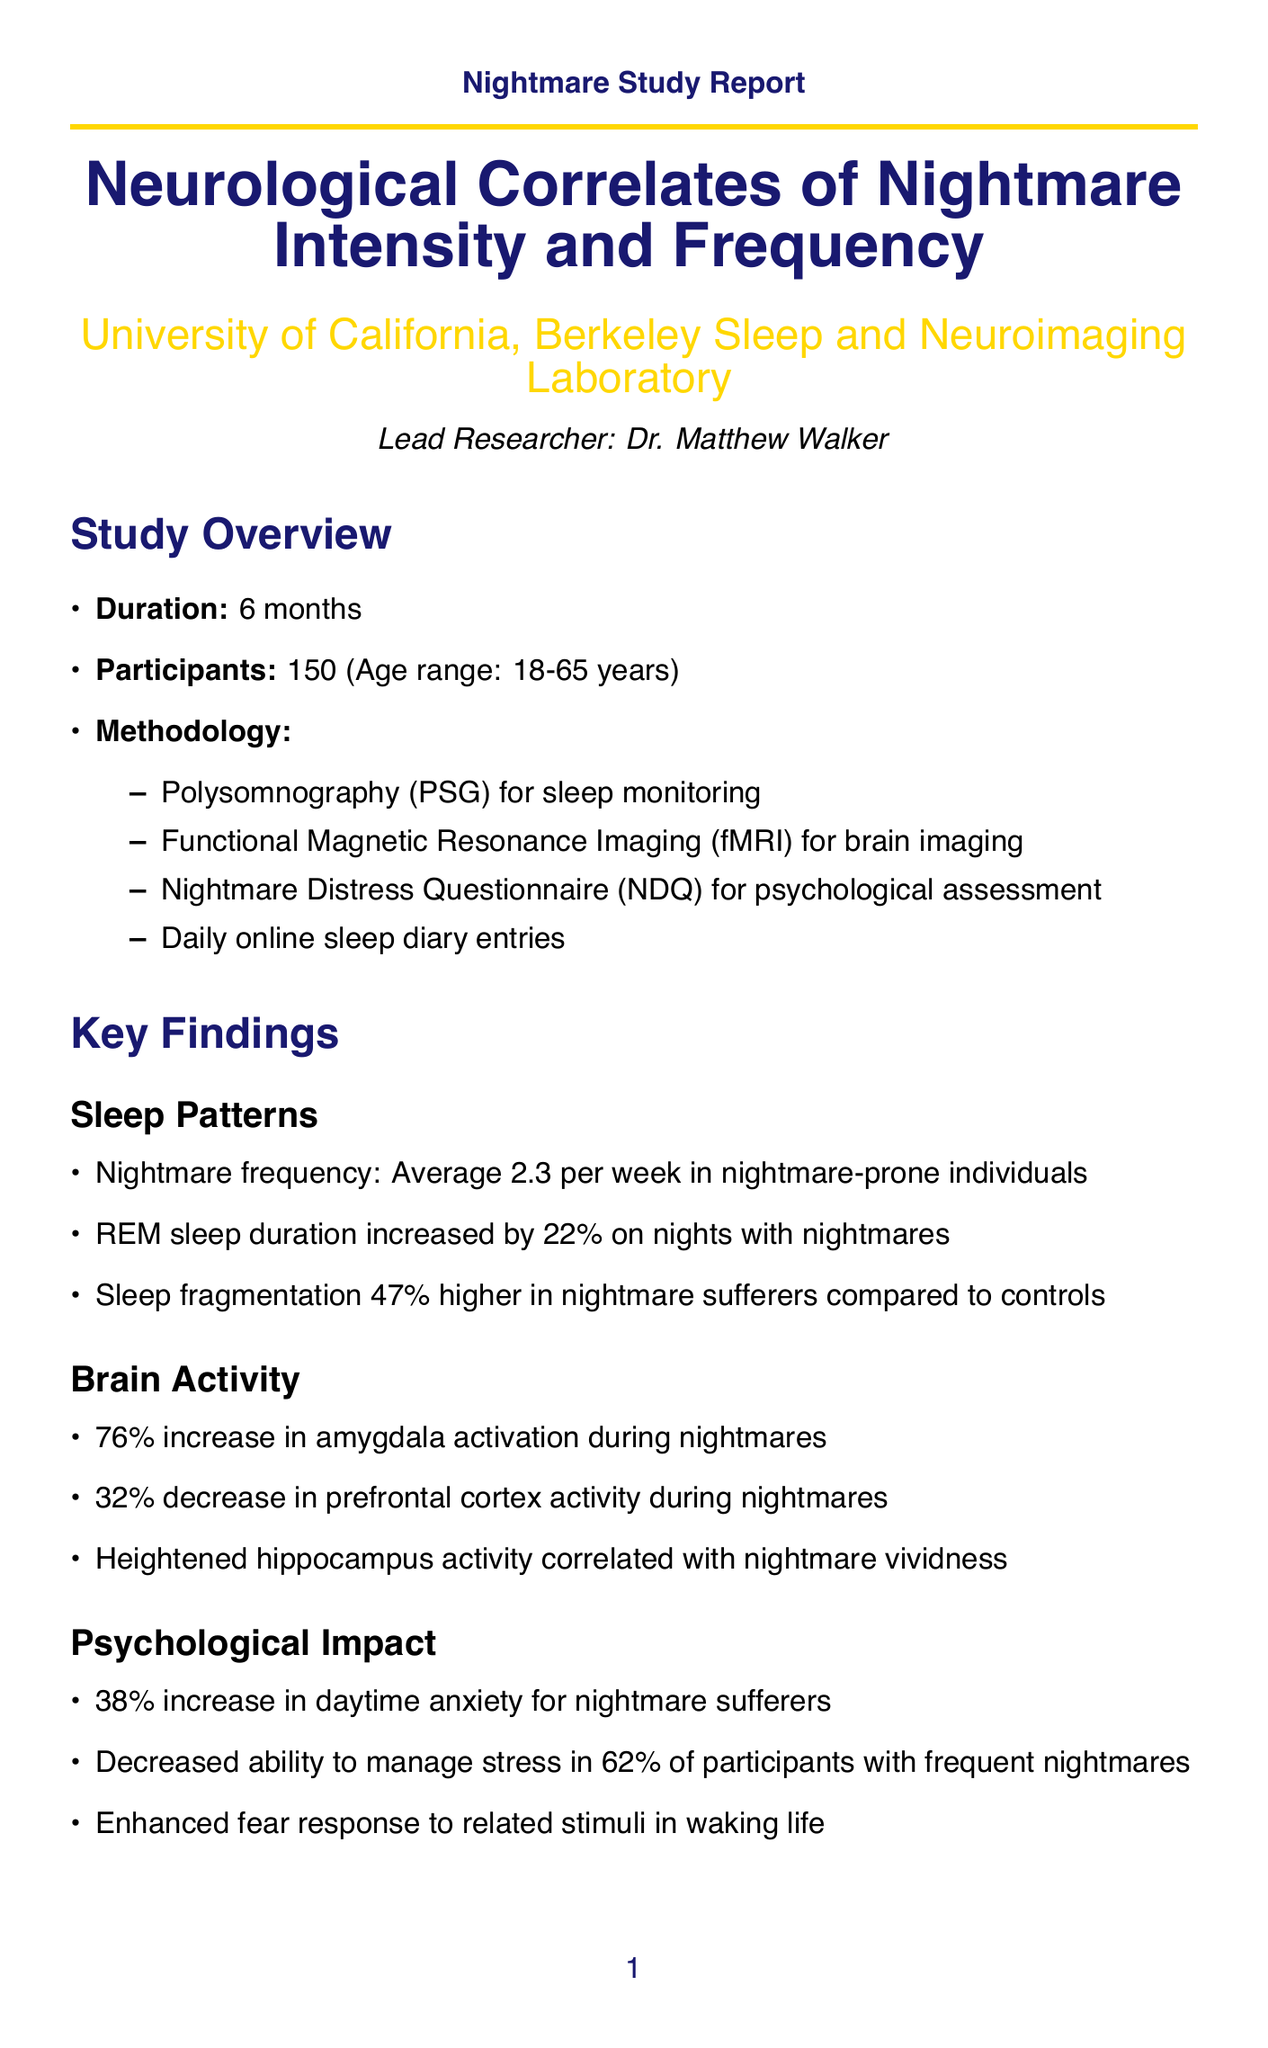What is the title of the study? The title of the study is explicitly mentioned in the document, which is "Neurological Correlates of Nightmare Intensity and Frequency."
Answer: Neurological Correlates of Nightmare Intensity and Frequency Who is the lead researcher? The document states the name of the lead researcher as "Dr. Matthew Walker."
Answer: Dr. Matthew Walker How long did the study last? The duration of the study is indicated as "6 months."
Answer: 6 months What is the increase in amygdala activation during nightmares? The document specifies a "76% increase during nightmares compared to normal dreams" for amygdala activation.
Answer: 76% increase What percentage of participants experienced a decrease in emotional regulation? The document notes that "62% of participants with frequent nightmares" reported a decreased ability to manage stress.
Answer: 62% What methodology was used for brain imaging? The document lists "Functional Magnetic Resonance Imaging (fMRI)" as the brain imaging technique employed in the study.
Answer: Functional Magnetic Resonance Imaging (fMRI) What potential therapeutic approaches are suggested for nightmare reduction? The document mentions "investigation of prazosin and image rehearsal therapy" as possible therapeutic approaches.
Answer: prazosin and image rehearsal therapy What is the average nightmare frequency in nightmare-prone individuals? The document provides that the "Average 2.3 per week in nightmare-prone individuals" regarding nightmare frequency.
Answer: 2.3 per week What aspect of partnering is suggested for collaboration? The document proposes "collaboration on fear response studies in waking state vs. dream state" as a potential area for partnership.
Answer: collaboration on fear response studies in waking state vs. dream state 